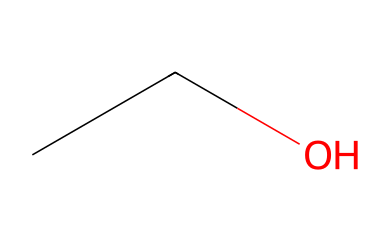How many carbon atoms are in this molecule? The SMILES representation "CCO" indicates that the molecule has two consecutive 'C' characters, which represent carbon atoms. Therefore, there are two carbon atoms present in the structure.
Answer: 2 What is the functional group present in ethanol? The structure contains an -OH group attached to one of the carbon atoms. This hydroxyl group is the defining feature of alcohols, identifying ethanol specifically.
Answer: hydroxyl How many hydrogen atoms are in ethanol? In the structure "CCO", each carbon typically bonds with enough hydrogen atoms to satisfy the tetravalency of carbon. The two carbon atoms contribute a maximum of 6 hydrogen atoms (3 from each carbon, minus 1 for the -OH bond), thus resulting in a total of 6 hydrogen atoms in ethanol.
Answer: 6 What type of solvent is ethanol classified as? Ethanol is polar due to its hydroxyl group which can form hydrogen bonds, making it effective for dissolving polar substances. Hence, it is classified as a polar solvent.
Answer: polar solven Why is ethanol commonly used in cleaning products? The hydroxyl group gives ethanol the ability to dissolve both polar (like water) and non-polar substances (like oils), making it effective in removing diverse types of residues. This unique solvency property is a significant reason for its use in cleaning products.
Answer: versatile solvent 